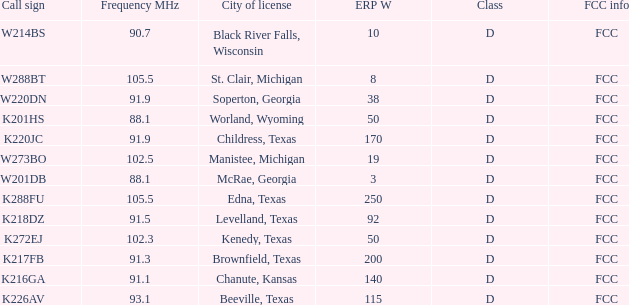What is Call Sign, when City of License is Brownfield, Texas? K217FB. 